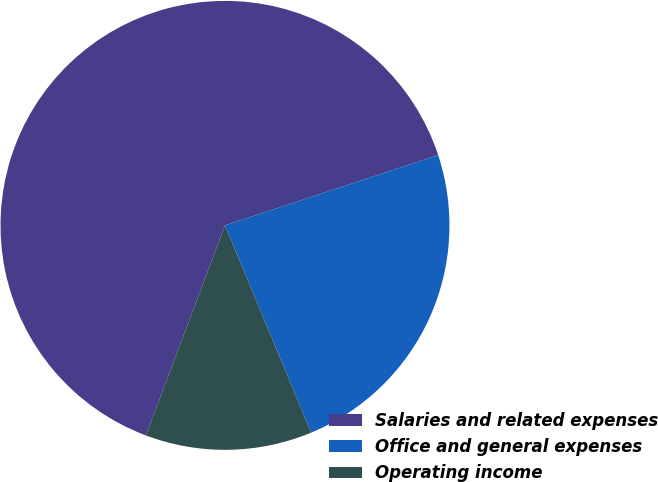<chart> <loc_0><loc_0><loc_500><loc_500><pie_chart><fcel>Salaries and related expenses<fcel>Office and general expenses<fcel>Operating income<nl><fcel>64.2%<fcel>23.8%<fcel>12.0%<nl></chart> 